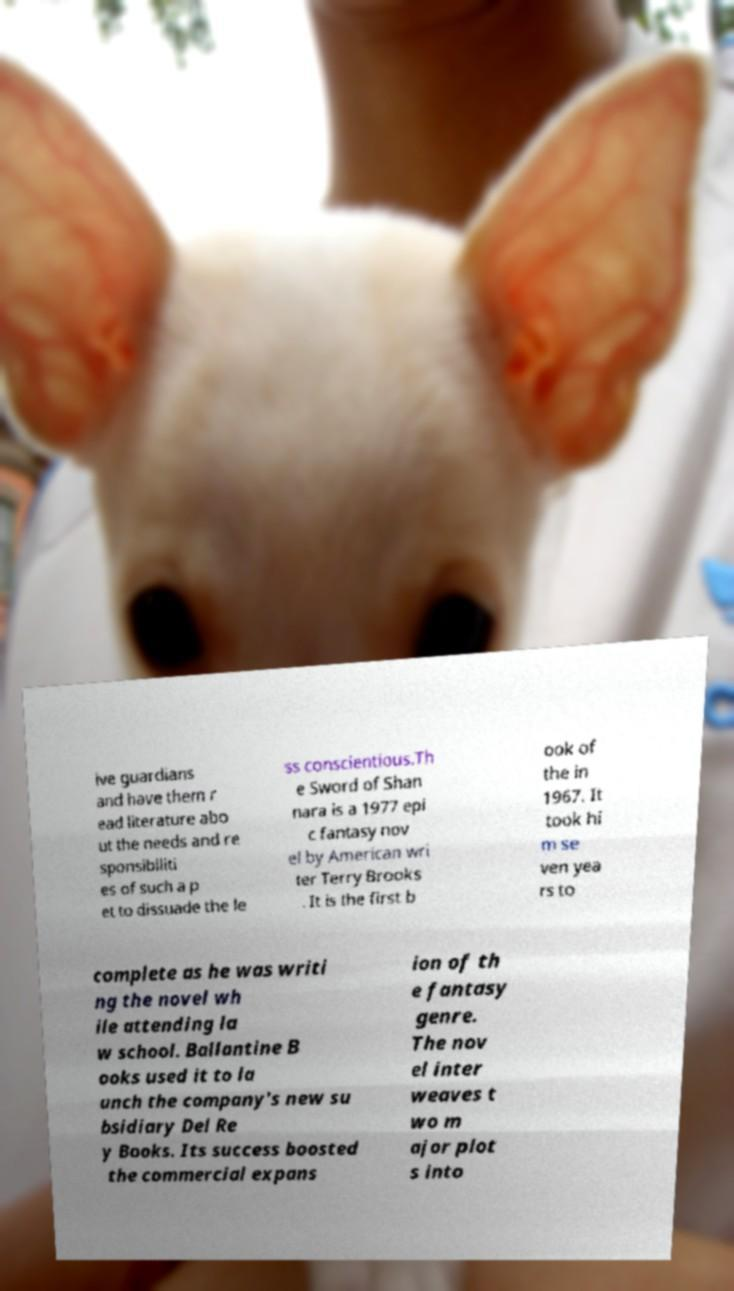Please read and relay the text visible in this image. What does it say? ive guardians and have them r ead literature abo ut the needs and re sponsibiliti es of such a p et to dissuade the le ss conscientious.Th e Sword of Shan nara is a 1977 epi c fantasy nov el by American wri ter Terry Brooks . It is the first b ook of the in 1967. It took hi m se ven yea rs to complete as he was writi ng the novel wh ile attending la w school. Ballantine B ooks used it to la unch the company's new su bsidiary Del Re y Books. Its success boosted the commercial expans ion of th e fantasy genre. The nov el inter weaves t wo m ajor plot s into 